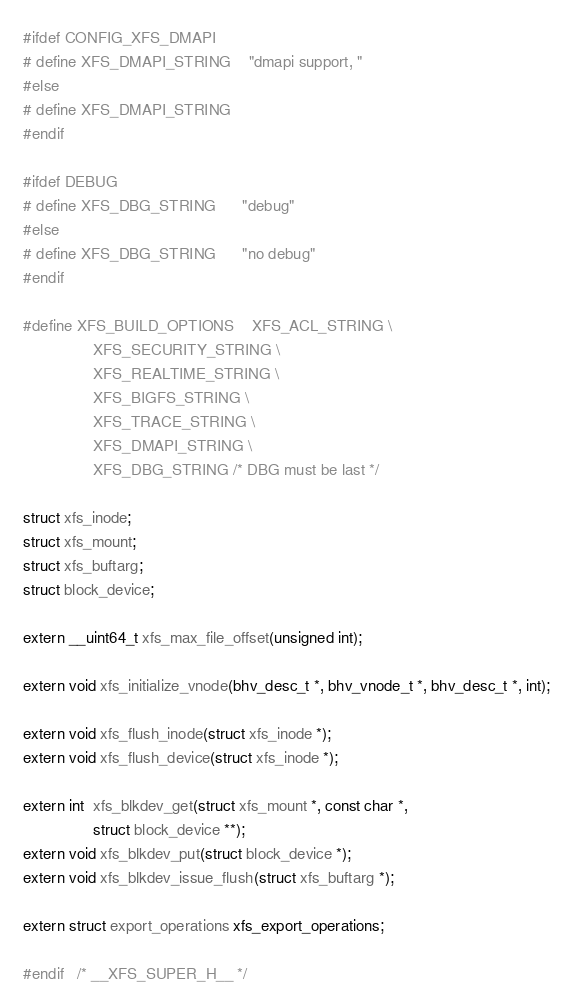<code> <loc_0><loc_0><loc_500><loc_500><_C_>#ifdef CONFIG_XFS_DMAPI
# define XFS_DMAPI_STRING	"dmapi support, "
#else
# define XFS_DMAPI_STRING
#endif

#ifdef DEBUG
# define XFS_DBG_STRING		"debug"
#else
# define XFS_DBG_STRING		"no debug"
#endif

#define XFS_BUILD_OPTIONS	XFS_ACL_STRING \
				XFS_SECURITY_STRING \
				XFS_REALTIME_STRING \
				XFS_BIGFS_STRING \
				XFS_TRACE_STRING \
				XFS_DMAPI_STRING \
				XFS_DBG_STRING /* DBG must be last */

struct xfs_inode;
struct xfs_mount;
struct xfs_buftarg;
struct block_device;

extern __uint64_t xfs_max_file_offset(unsigned int);

extern void xfs_initialize_vnode(bhv_desc_t *, bhv_vnode_t *, bhv_desc_t *, int);

extern void xfs_flush_inode(struct xfs_inode *);
extern void xfs_flush_device(struct xfs_inode *);

extern int  xfs_blkdev_get(struct xfs_mount *, const char *,
				struct block_device **);
extern void xfs_blkdev_put(struct block_device *);
extern void xfs_blkdev_issue_flush(struct xfs_buftarg *);

extern struct export_operations xfs_export_operations;

#endif	/* __XFS_SUPER_H__ */
</code> 